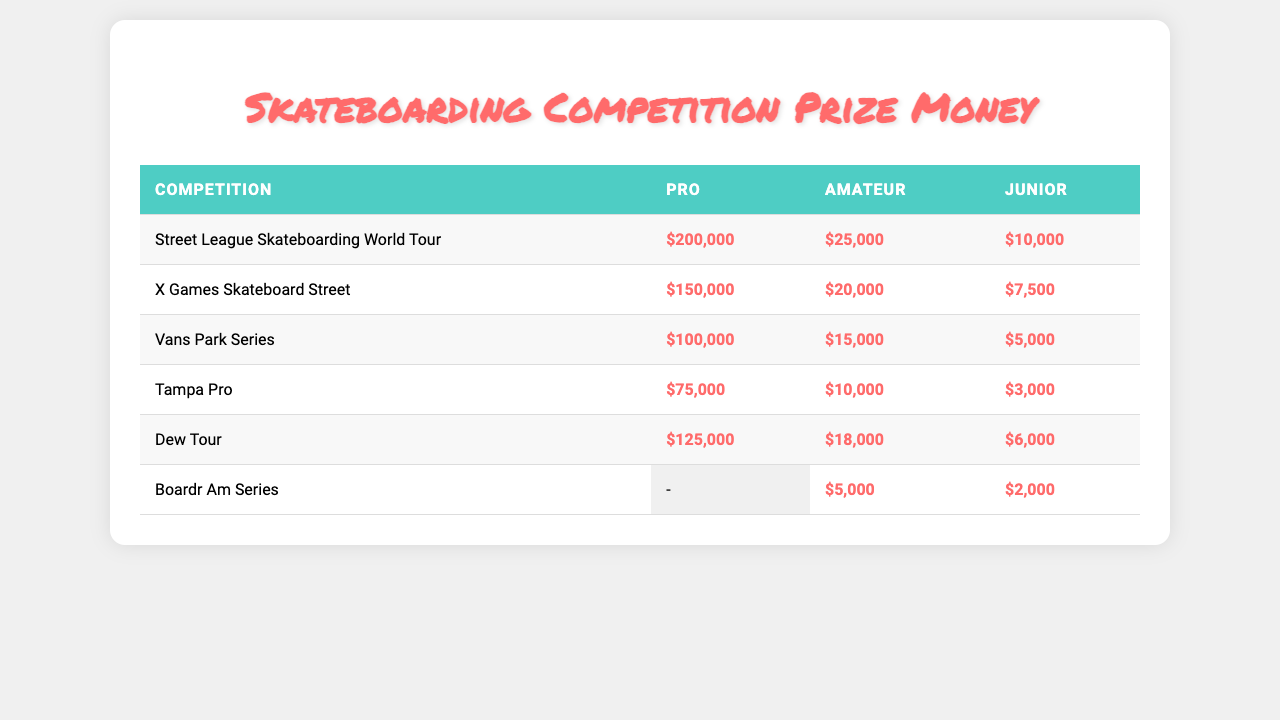What is the prize money for the Pro level in the Street League Skateboarding World Tour? The table shows that the prize money for the Pro level in the Street League Skateboarding World Tour is listed as $200,000.
Answer: $200,000 Which competition has the highest prize money for the Amateur level? By comparing the prize money for the Amateur levels across competitions, the Street League Skateboarding World Tour offers the highest at $25,000.
Answer: Street League Skateboarding World Tour What is the total prize money for Junior level across all competitions? Adding the Junior prizes: 10,000 (Street League) + 7,500 (X Games) + 5,000 (Vans Park) + 3,000 (Tampa Pro) + 6,000 (Dew Tour) + 2,000 (Boardr Am Series) gives a total of 33,500.
Answer: $33,500 Is there any prize money allocated for the Junior level in the Boardr Am Series? The table indicates that there is no prize money listed for the Junior level in the Boardr Am Series; it shows only $5,000 for Amateur and $2,000 for Junior.
Answer: Yes, $2,000 What is the difference in prize money between the Pro and Amateur levels in the Dew Tour? The prize money for Pro in Dew Tour is $125,000, and for Amateur, it's $18,000. The difference is calculated as 125,000 - 18,000 = 107,000.
Answer: $107,000 How much was the total prize money for the Pro level across all competitions? The total is calculated by summing the Pro level prizes: 200,000 (Street League) + 150,000 (X Games) + 100,000 (Vans Park) + 75,000 (Tampa Pro) + 125,000 (Dew Tour) = 650,000.
Answer: $650,000 Which competition offers no prize money for the Pro level? The Boardr Am Series does not list any amount for the Pro category, as it only has Amateur and Junior levels.
Answer: Boardr Am Series What is the average prize money for the Junior level across all competitions? Summing the Junior prizes gives $33,500 as calculated earlier, and since there are five competitions that offer a Junior prize, we divide this total by 5, resulting in an average of 33,500/5 = 6,700.
Answer: $6,700 How much less is the prize money for Juniors in the Tampa Pro compared to the Vans Park Series? The Junior prize in Tampa Pro is $3,000 and in Vans Park Series is $5,000. So, $5,000 - $3,000 results in a difference of $2,000.
Answer: $2,000 Was there any competition listed that did not award any prize money for the Junior level? The Boardr Am Series does not list any prize for the Junior level, indicating it awarded $0 for that category.
Answer: Yes, Boardr Am Series 